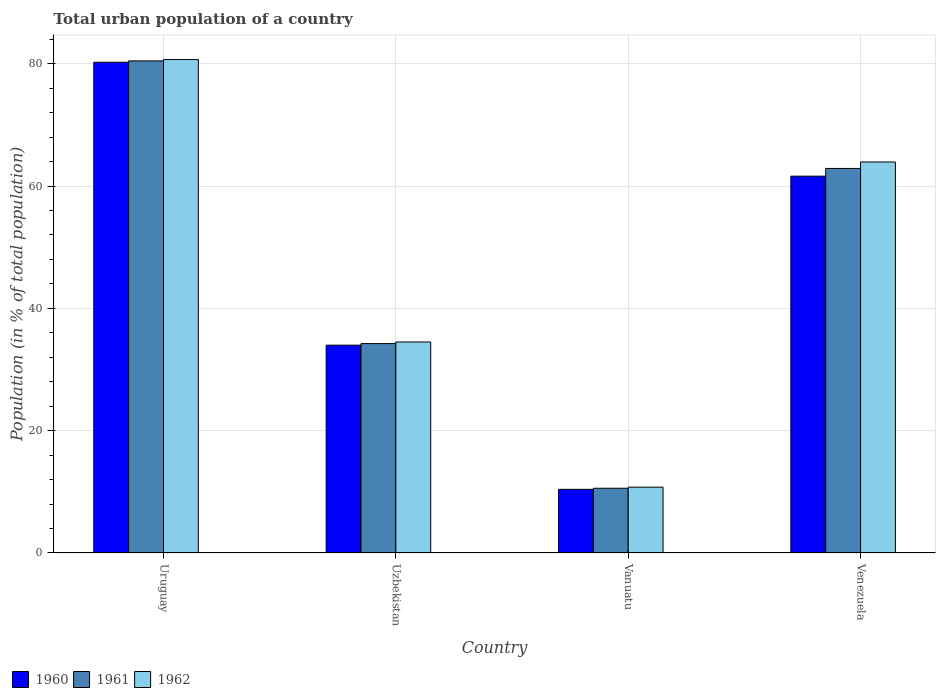How many different coloured bars are there?
Your response must be concise. 3. Are the number of bars on each tick of the X-axis equal?
Ensure brevity in your answer.  Yes. How many bars are there on the 2nd tick from the right?
Your response must be concise. 3. What is the label of the 3rd group of bars from the left?
Make the answer very short. Vanuatu. What is the urban population in 1962 in Uruguay?
Your response must be concise. 80.68. Across all countries, what is the maximum urban population in 1961?
Your answer should be compact. 80.46. Across all countries, what is the minimum urban population in 1962?
Keep it short and to the point. 10.77. In which country was the urban population in 1960 maximum?
Offer a very short reply. Uruguay. In which country was the urban population in 1960 minimum?
Your answer should be compact. Vanuatu. What is the total urban population in 1962 in the graph?
Make the answer very short. 189.88. What is the difference between the urban population in 1962 in Uruguay and that in Vanuatu?
Keep it short and to the point. 69.92. What is the difference between the urban population in 1961 in Uzbekistan and the urban population in 1962 in Vanuatu?
Offer a terse response. 23.47. What is the average urban population in 1960 per country?
Ensure brevity in your answer.  46.56. What is the difference between the urban population of/in 1961 and urban population of/in 1962 in Uzbekistan?
Provide a succinct answer. -0.26. In how many countries, is the urban population in 1960 greater than 8 %?
Your response must be concise. 4. What is the ratio of the urban population in 1961 in Uruguay to that in Uzbekistan?
Offer a terse response. 2.35. Is the urban population in 1962 in Uruguay less than that in Venezuela?
Your answer should be very brief. No. Is the difference between the urban population in 1961 in Uruguay and Venezuela greater than the difference between the urban population in 1962 in Uruguay and Venezuela?
Give a very brief answer. Yes. What is the difference between the highest and the second highest urban population in 1960?
Offer a terse response. 46.26. What is the difference between the highest and the lowest urban population in 1962?
Make the answer very short. 69.92. Is the sum of the urban population in 1960 in Uruguay and Uzbekistan greater than the maximum urban population in 1962 across all countries?
Give a very brief answer. Yes. Are all the bars in the graph horizontal?
Give a very brief answer. No. What is the difference between two consecutive major ticks on the Y-axis?
Keep it short and to the point. 20. Where does the legend appear in the graph?
Offer a terse response. Bottom left. What is the title of the graph?
Make the answer very short. Total urban population of a country. What is the label or title of the Y-axis?
Offer a very short reply. Population (in % of total population). What is the Population (in % of total population) in 1960 in Uruguay?
Give a very brief answer. 80.24. What is the Population (in % of total population) in 1961 in Uruguay?
Ensure brevity in your answer.  80.46. What is the Population (in % of total population) of 1962 in Uruguay?
Your answer should be compact. 80.68. What is the Population (in % of total population) of 1960 in Uzbekistan?
Offer a very short reply. 33.98. What is the Population (in % of total population) of 1961 in Uzbekistan?
Give a very brief answer. 34.24. What is the Population (in % of total population) in 1962 in Uzbekistan?
Ensure brevity in your answer.  34.5. What is the Population (in % of total population) in 1960 in Vanuatu?
Make the answer very short. 10.4. What is the Population (in % of total population) of 1961 in Vanuatu?
Offer a very short reply. 10.58. What is the Population (in % of total population) of 1962 in Vanuatu?
Ensure brevity in your answer.  10.77. What is the Population (in % of total population) of 1960 in Venezuela?
Offer a very short reply. 61.61. What is the Population (in % of total population) of 1961 in Venezuela?
Offer a terse response. 62.88. What is the Population (in % of total population) in 1962 in Venezuela?
Provide a succinct answer. 63.93. Across all countries, what is the maximum Population (in % of total population) of 1960?
Offer a very short reply. 80.24. Across all countries, what is the maximum Population (in % of total population) in 1961?
Offer a terse response. 80.46. Across all countries, what is the maximum Population (in % of total population) in 1962?
Give a very brief answer. 80.68. Across all countries, what is the minimum Population (in % of total population) in 1960?
Your answer should be compact. 10.4. Across all countries, what is the minimum Population (in % of total population) in 1961?
Provide a succinct answer. 10.58. Across all countries, what is the minimum Population (in % of total population) in 1962?
Your answer should be compact. 10.77. What is the total Population (in % of total population) of 1960 in the graph?
Ensure brevity in your answer.  186.24. What is the total Population (in % of total population) in 1961 in the graph?
Give a very brief answer. 188.16. What is the total Population (in % of total population) in 1962 in the graph?
Ensure brevity in your answer.  189.88. What is the difference between the Population (in % of total population) in 1960 in Uruguay and that in Uzbekistan?
Offer a terse response. 46.26. What is the difference between the Population (in % of total population) in 1961 in Uruguay and that in Uzbekistan?
Keep it short and to the point. 46.22. What is the difference between the Population (in % of total population) of 1962 in Uruguay and that in Uzbekistan?
Your answer should be very brief. 46.18. What is the difference between the Population (in % of total population) of 1960 in Uruguay and that in Vanuatu?
Your response must be concise. 69.84. What is the difference between the Population (in % of total population) of 1961 in Uruguay and that in Vanuatu?
Offer a very short reply. 69.88. What is the difference between the Population (in % of total population) of 1962 in Uruguay and that in Vanuatu?
Keep it short and to the point. 69.92. What is the difference between the Population (in % of total population) of 1960 in Uruguay and that in Venezuela?
Give a very brief answer. 18.63. What is the difference between the Population (in % of total population) in 1961 in Uruguay and that in Venezuela?
Keep it short and to the point. 17.59. What is the difference between the Population (in % of total population) of 1962 in Uruguay and that in Venezuela?
Offer a terse response. 16.75. What is the difference between the Population (in % of total population) of 1960 in Uzbekistan and that in Vanuatu?
Your response must be concise. 23.57. What is the difference between the Population (in % of total population) of 1961 in Uzbekistan and that in Vanuatu?
Make the answer very short. 23.66. What is the difference between the Population (in % of total population) in 1962 in Uzbekistan and that in Vanuatu?
Make the answer very short. 23.73. What is the difference between the Population (in % of total population) in 1960 in Uzbekistan and that in Venezuela?
Offer a very short reply. -27.64. What is the difference between the Population (in % of total population) of 1961 in Uzbekistan and that in Venezuela?
Your answer should be very brief. -28.64. What is the difference between the Population (in % of total population) of 1962 in Uzbekistan and that in Venezuela?
Ensure brevity in your answer.  -29.43. What is the difference between the Population (in % of total population) of 1960 in Vanuatu and that in Venezuela?
Give a very brief answer. -51.21. What is the difference between the Population (in % of total population) of 1961 in Vanuatu and that in Venezuela?
Ensure brevity in your answer.  -52.29. What is the difference between the Population (in % of total population) in 1962 in Vanuatu and that in Venezuela?
Offer a terse response. -53.17. What is the difference between the Population (in % of total population) of 1960 in Uruguay and the Population (in % of total population) of 1961 in Uzbekistan?
Offer a terse response. 46. What is the difference between the Population (in % of total population) of 1960 in Uruguay and the Population (in % of total population) of 1962 in Uzbekistan?
Provide a short and direct response. 45.74. What is the difference between the Population (in % of total population) in 1961 in Uruguay and the Population (in % of total population) in 1962 in Uzbekistan?
Make the answer very short. 45.96. What is the difference between the Population (in % of total population) of 1960 in Uruguay and the Population (in % of total population) of 1961 in Vanuatu?
Keep it short and to the point. 69.66. What is the difference between the Population (in % of total population) of 1960 in Uruguay and the Population (in % of total population) of 1962 in Vanuatu?
Provide a short and direct response. 69.48. What is the difference between the Population (in % of total population) in 1961 in Uruguay and the Population (in % of total population) in 1962 in Vanuatu?
Your answer should be compact. 69.7. What is the difference between the Population (in % of total population) in 1960 in Uruguay and the Population (in % of total population) in 1961 in Venezuela?
Your answer should be compact. 17.37. What is the difference between the Population (in % of total population) of 1960 in Uruguay and the Population (in % of total population) of 1962 in Venezuela?
Provide a short and direct response. 16.31. What is the difference between the Population (in % of total population) of 1961 in Uruguay and the Population (in % of total population) of 1962 in Venezuela?
Give a very brief answer. 16.53. What is the difference between the Population (in % of total population) of 1960 in Uzbekistan and the Population (in % of total population) of 1961 in Vanuatu?
Offer a very short reply. 23.39. What is the difference between the Population (in % of total population) in 1960 in Uzbekistan and the Population (in % of total population) in 1962 in Vanuatu?
Make the answer very short. 23.21. What is the difference between the Population (in % of total population) in 1961 in Uzbekistan and the Population (in % of total population) in 1962 in Vanuatu?
Keep it short and to the point. 23.47. What is the difference between the Population (in % of total population) in 1960 in Uzbekistan and the Population (in % of total population) in 1961 in Venezuela?
Give a very brief answer. -28.9. What is the difference between the Population (in % of total population) in 1960 in Uzbekistan and the Population (in % of total population) in 1962 in Venezuela?
Offer a very short reply. -29.95. What is the difference between the Population (in % of total population) in 1961 in Uzbekistan and the Population (in % of total population) in 1962 in Venezuela?
Ensure brevity in your answer.  -29.7. What is the difference between the Population (in % of total population) in 1960 in Vanuatu and the Population (in % of total population) in 1961 in Venezuela?
Keep it short and to the point. -52.47. What is the difference between the Population (in % of total population) in 1960 in Vanuatu and the Population (in % of total population) in 1962 in Venezuela?
Your response must be concise. -53.53. What is the difference between the Population (in % of total population) in 1961 in Vanuatu and the Population (in % of total population) in 1962 in Venezuela?
Provide a succinct answer. -53.35. What is the average Population (in % of total population) in 1960 per country?
Ensure brevity in your answer.  46.56. What is the average Population (in % of total population) of 1961 per country?
Make the answer very short. 47.04. What is the average Population (in % of total population) of 1962 per country?
Offer a very short reply. 47.47. What is the difference between the Population (in % of total population) in 1960 and Population (in % of total population) in 1961 in Uruguay?
Provide a short and direct response. -0.22. What is the difference between the Population (in % of total population) in 1960 and Population (in % of total population) in 1962 in Uruguay?
Your response must be concise. -0.44. What is the difference between the Population (in % of total population) of 1961 and Population (in % of total population) of 1962 in Uruguay?
Your answer should be very brief. -0.22. What is the difference between the Population (in % of total population) in 1960 and Population (in % of total population) in 1961 in Uzbekistan?
Your answer should be compact. -0.26. What is the difference between the Population (in % of total population) in 1960 and Population (in % of total population) in 1962 in Uzbekistan?
Keep it short and to the point. -0.52. What is the difference between the Population (in % of total population) in 1961 and Population (in % of total population) in 1962 in Uzbekistan?
Give a very brief answer. -0.26. What is the difference between the Population (in % of total population) in 1960 and Population (in % of total population) in 1961 in Vanuatu?
Provide a succinct answer. -0.18. What is the difference between the Population (in % of total population) in 1960 and Population (in % of total population) in 1962 in Vanuatu?
Offer a very short reply. -0.36. What is the difference between the Population (in % of total population) in 1961 and Population (in % of total population) in 1962 in Vanuatu?
Your answer should be very brief. -0.18. What is the difference between the Population (in % of total population) in 1960 and Population (in % of total population) in 1961 in Venezuela?
Your answer should be compact. -1.26. What is the difference between the Population (in % of total population) in 1960 and Population (in % of total population) in 1962 in Venezuela?
Provide a short and direct response. -2.32. What is the difference between the Population (in % of total population) in 1961 and Population (in % of total population) in 1962 in Venezuela?
Your response must be concise. -1.06. What is the ratio of the Population (in % of total population) of 1960 in Uruguay to that in Uzbekistan?
Offer a terse response. 2.36. What is the ratio of the Population (in % of total population) of 1961 in Uruguay to that in Uzbekistan?
Your answer should be very brief. 2.35. What is the ratio of the Population (in % of total population) of 1962 in Uruguay to that in Uzbekistan?
Offer a terse response. 2.34. What is the ratio of the Population (in % of total population) of 1960 in Uruguay to that in Vanuatu?
Give a very brief answer. 7.71. What is the ratio of the Population (in % of total population) in 1961 in Uruguay to that in Vanuatu?
Your answer should be very brief. 7.6. What is the ratio of the Population (in % of total population) of 1962 in Uruguay to that in Vanuatu?
Offer a very short reply. 7.49. What is the ratio of the Population (in % of total population) in 1960 in Uruguay to that in Venezuela?
Offer a very short reply. 1.3. What is the ratio of the Population (in % of total population) in 1961 in Uruguay to that in Venezuela?
Offer a very short reply. 1.28. What is the ratio of the Population (in % of total population) of 1962 in Uruguay to that in Venezuela?
Offer a terse response. 1.26. What is the ratio of the Population (in % of total population) of 1960 in Uzbekistan to that in Vanuatu?
Your answer should be compact. 3.27. What is the ratio of the Population (in % of total population) in 1961 in Uzbekistan to that in Vanuatu?
Provide a short and direct response. 3.24. What is the ratio of the Population (in % of total population) in 1962 in Uzbekistan to that in Vanuatu?
Give a very brief answer. 3.2. What is the ratio of the Population (in % of total population) in 1960 in Uzbekistan to that in Venezuela?
Keep it short and to the point. 0.55. What is the ratio of the Population (in % of total population) of 1961 in Uzbekistan to that in Venezuela?
Make the answer very short. 0.54. What is the ratio of the Population (in % of total population) in 1962 in Uzbekistan to that in Venezuela?
Provide a succinct answer. 0.54. What is the ratio of the Population (in % of total population) of 1960 in Vanuatu to that in Venezuela?
Make the answer very short. 0.17. What is the ratio of the Population (in % of total population) in 1961 in Vanuatu to that in Venezuela?
Provide a succinct answer. 0.17. What is the ratio of the Population (in % of total population) of 1962 in Vanuatu to that in Venezuela?
Give a very brief answer. 0.17. What is the difference between the highest and the second highest Population (in % of total population) of 1960?
Provide a short and direct response. 18.63. What is the difference between the highest and the second highest Population (in % of total population) in 1961?
Provide a succinct answer. 17.59. What is the difference between the highest and the second highest Population (in % of total population) of 1962?
Offer a terse response. 16.75. What is the difference between the highest and the lowest Population (in % of total population) of 1960?
Make the answer very short. 69.84. What is the difference between the highest and the lowest Population (in % of total population) in 1961?
Provide a succinct answer. 69.88. What is the difference between the highest and the lowest Population (in % of total population) of 1962?
Make the answer very short. 69.92. 